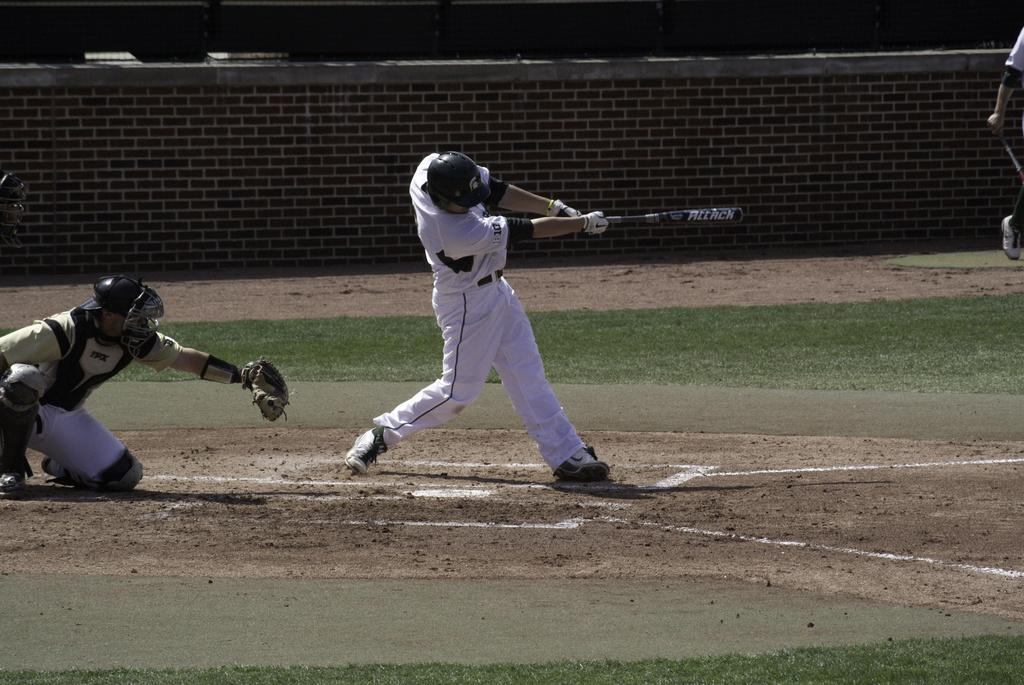How many people are playing baseball in the image? There are four persons in the image playing baseball. What is the setting of the baseball game? The game is being played on the ground. What can be seen in the background of the image? There is a wall fence in the background of the image. When was the image taken? The image was taken during the day. What type of polish is being applied to the baseball bat in the image? There is no indication in the image that any polish is being applied to a baseball bat, as the focus is on the game being played. 